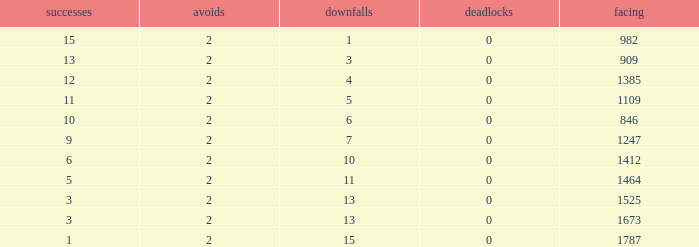What is the highest number listed under against when there were 15 losses and more than 1 win? None. 